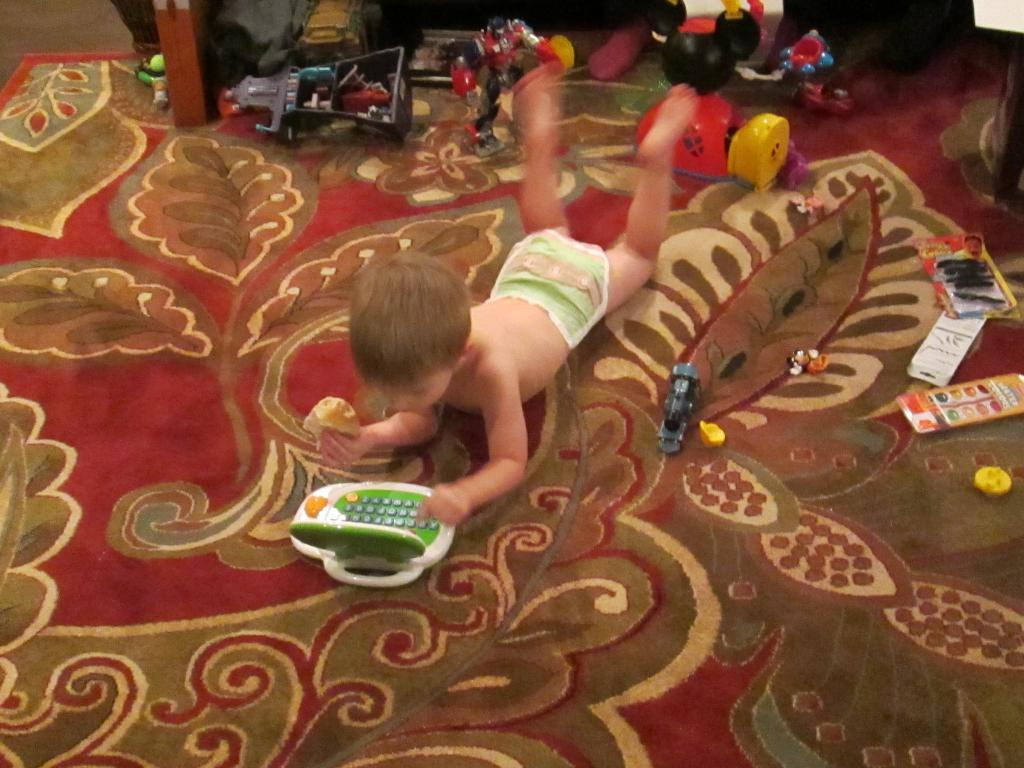What is the position of the kid in the image? The kid is lying down in the image. What can be seen around the kid? There are toys around the kid in the image. What type of knife is the kid using to cut the leaf in the image? There is no knife or leaf present in the image; the kid is surrounded by toys. 